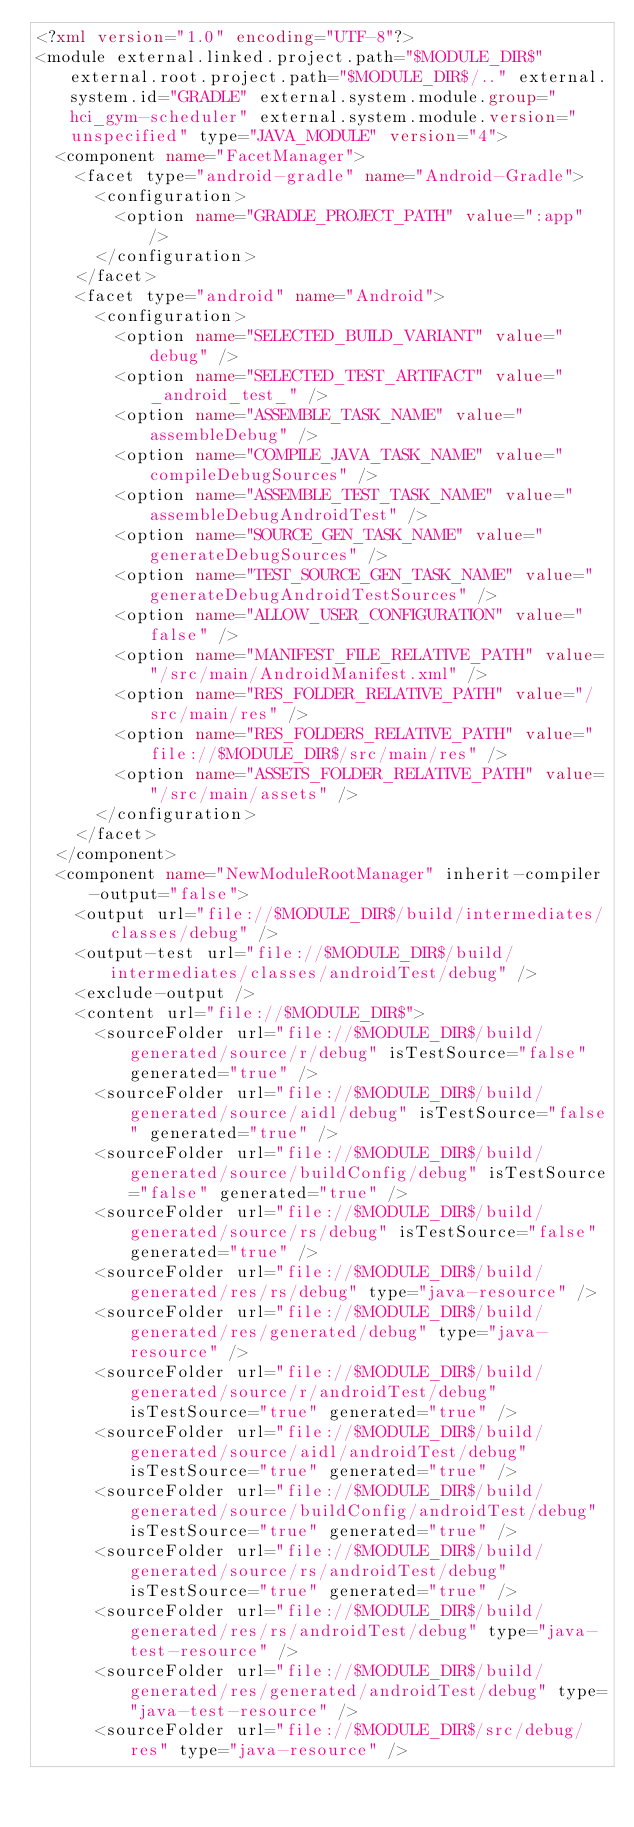Convert code to text. <code><loc_0><loc_0><loc_500><loc_500><_XML_><?xml version="1.0" encoding="UTF-8"?>
<module external.linked.project.path="$MODULE_DIR$" external.root.project.path="$MODULE_DIR$/.." external.system.id="GRADLE" external.system.module.group="hci_gym-scheduler" external.system.module.version="unspecified" type="JAVA_MODULE" version="4">
  <component name="FacetManager">
    <facet type="android-gradle" name="Android-Gradle">
      <configuration>
        <option name="GRADLE_PROJECT_PATH" value=":app" />
      </configuration>
    </facet>
    <facet type="android" name="Android">
      <configuration>
        <option name="SELECTED_BUILD_VARIANT" value="debug" />
        <option name="SELECTED_TEST_ARTIFACT" value="_android_test_" />
        <option name="ASSEMBLE_TASK_NAME" value="assembleDebug" />
        <option name="COMPILE_JAVA_TASK_NAME" value="compileDebugSources" />
        <option name="ASSEMBLE_TEST_TASK_NAME" value="assembleDebugAndroidTest" />
        <option name="SOURCE_GEN_TASK_NAME" value="generateDebugSources" />
        <option name="TEST_SOURCE_GEN_TASK_NAME" value="generateDebugAndroidTestSources" />
        <option name="ALLOW_USER_CONFIGURATION" value="false" />
        <option name="MANIFEST_FILE_RELATIVE_PATH" value="/src/main/AndroidManifest.xml" />
        <option name="RES_FOLDER_RELATIVE_PATH" value="/src/main/res" />
        <option name="RES_FOLDERS_RELATIVE_PATH" value="file://$MODULE_DIR$/src/main/res" />
        <option name="ASSETS_FOLDER_RELATIVE_PATH" value="/src/main/assets" />
      </configuration>
    </facet>
  </component>
  <component name="NewModuleRootManager" inherit-compiler-output="false">
    <output url="file://$MODULE_DIR$/build/intermediates/classes/debug" />
    <output-test url="file://$MODULE_DIR$/build/intermediates/classes/androidTest/debug" />
    <exclude-output />
    <content url="file://$MODULE_DIR$">
      <sourceFolder url="file://$MODULE_DIR$/build/generated/source/r/debug" isTestSource="false" generated="true" />
      <sourceFolder url="file://$MODULE_DIR$/build/generated/source/aidl/debug" isTestSource="false" generated="true" />
      <sourceFolder url="file://$MODULE_DIR$/build/generated/source/buildConfig/debug" isTestSource="false" generated="true" />
      <sourceFolder url="file://$MODULE_DIR$/build/generated/source/rs/debug" isTestSource="false" generated="true" />
      <sourceFolder url="file://$MODULE_DIR$/build/generated/res/rs/debug" type="java-resource" />
      <sourceFolder url="file://$MODULE_DIR$/build/generated/res/generated/debug" type="java-resource" />
      <sourceFolder url="file://$MODULE_DIR$/build/generated/source/r/androidTest/debug" isTestSource="true" generated="true" />
      <sourceFolder url="file://$MODULE_DIR$/build/generated/source/aidl/androidTest/debug" isTestSource="true" generated="true" />
      <sourceFolder url="file://$MODULE_DIR$/build/generated/source/buildConfig/androidTest/debug" isTestSource="true" generated="true" />
      <sourceFolder url="file://$MODULE_DIR$/build/generated/source/rs/androidTest/debug" isTestSource="true" generated="true" />
      <sourceFolder url="file://$MODULE_DIR$/build/generated/res/rs/androidTest/debug" type="java-test-resource" />
      <sourceFolder url="file://$MODULE_DIR$/build/generated/res/generated/androidTest/debug" type="java-test-resource" />
      <sourceFolder url="file://$MODULE_DIR$/src/debug/res" type="java-resource" /></code> 